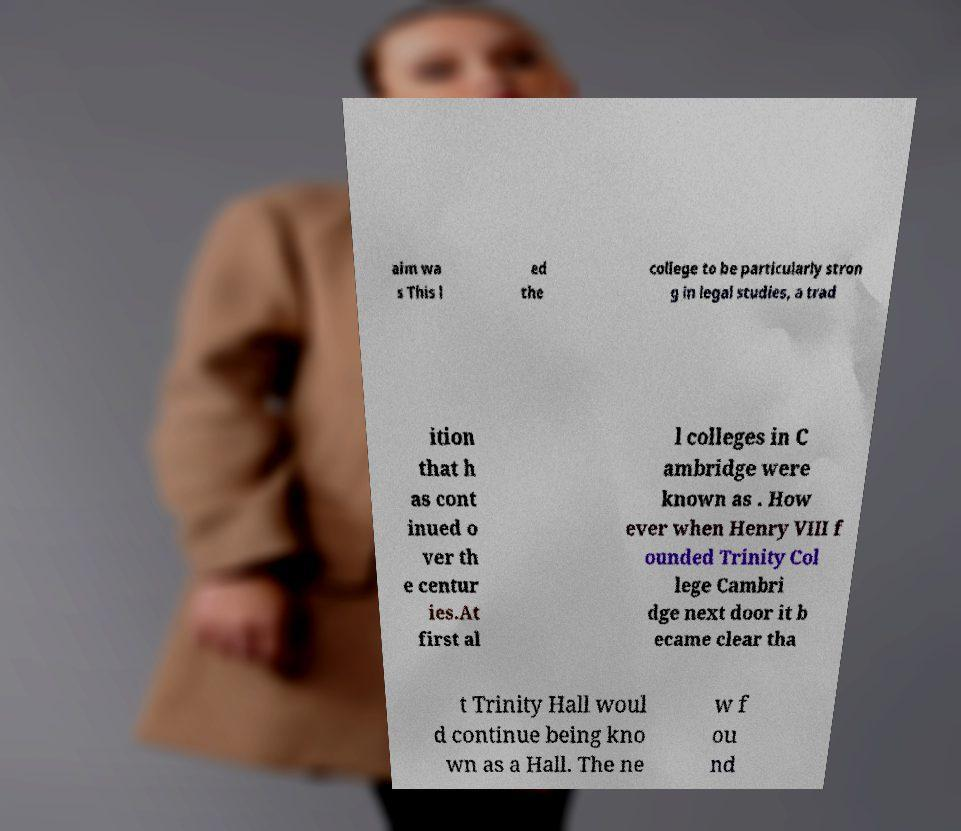Could you assist in decoding the text presented in this image and type it out clearly? aim wa s This l ed the college to be particularly stron g in legal studies, a trad ition that h as cont inued o ver th e centur ies.At first al l colleges in C ambridge were known as . How ever when Henry VIII f ounded Trinity Col lege Cambri dge next door it b ecame clear tha t Trinity Hall woul d continue being kno wn as a Hall. The ne w f ou nd 